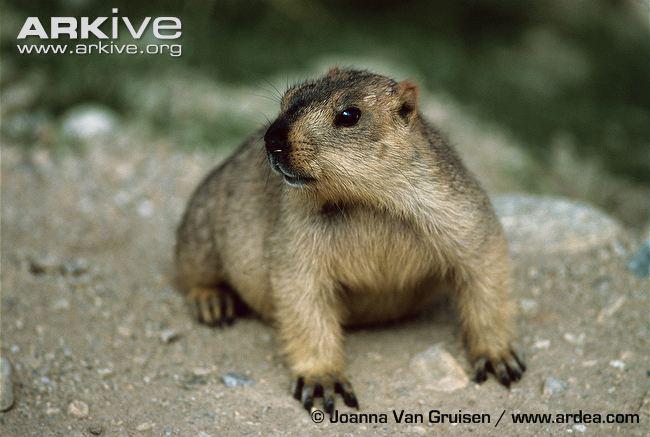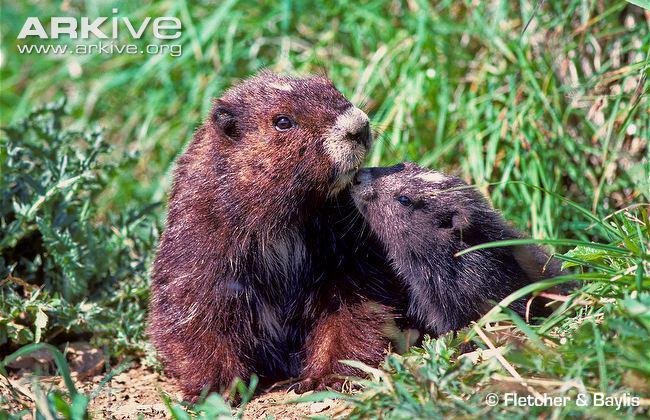The first image is the image on the left, the second image is the image on the right. Considering the images on both sides, is "One image shows two marmots posed face-to-face, and the other image shows one marmot on all fours on a rock." valid? Answer yes or no. Yes. The first image is the image on the left, the second image is the image on the right. For the images shown, is this caption "There are three marmots." true? Answer yes or no. Yes. 